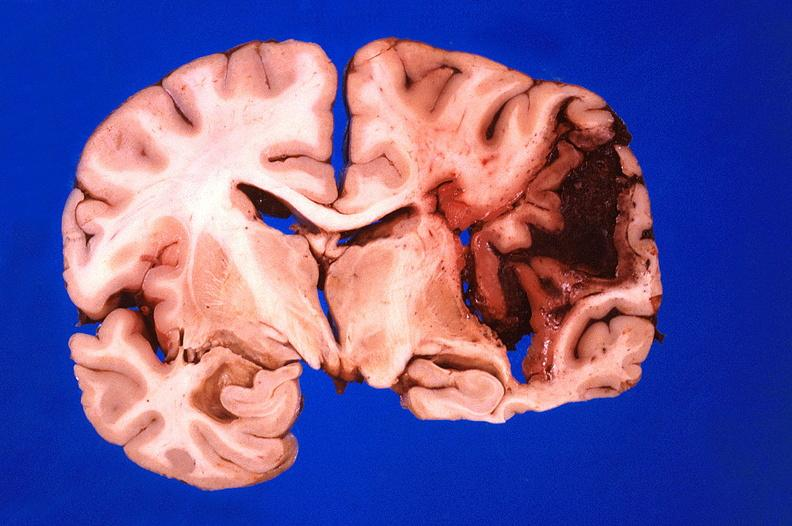s a bulge present?
Answer the question using a single word or phrase. No 